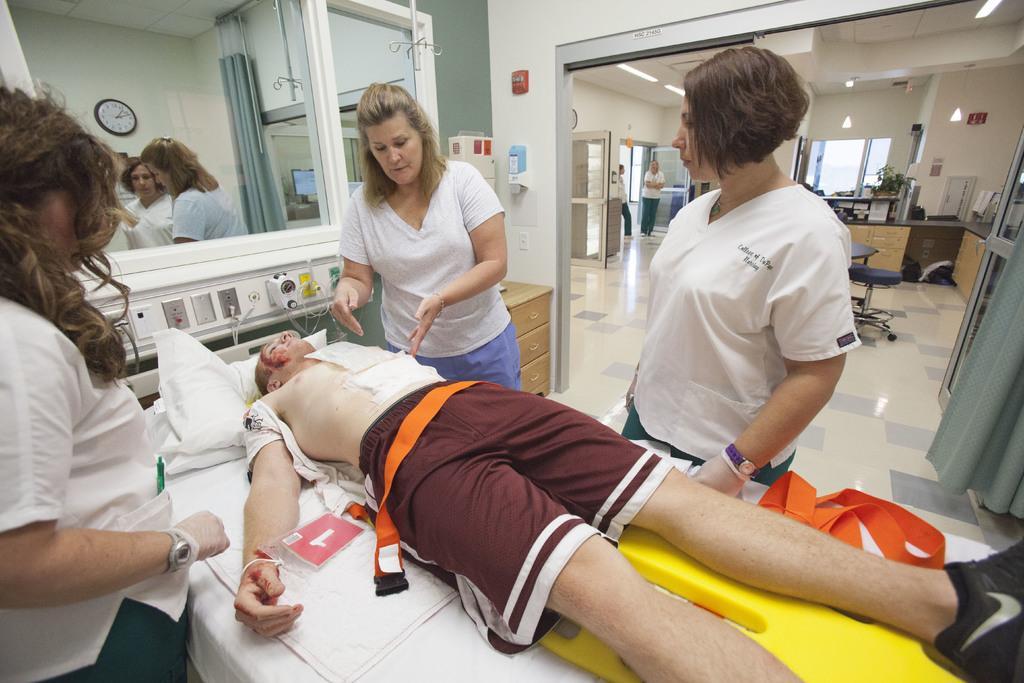In one or two sentences, can you explain what this image depicts? In this image I can see few people and one person is lying on the bed. I can see few glass doors, curtains, chair, system, plants and few objects around. The clock is attached to the wall. 